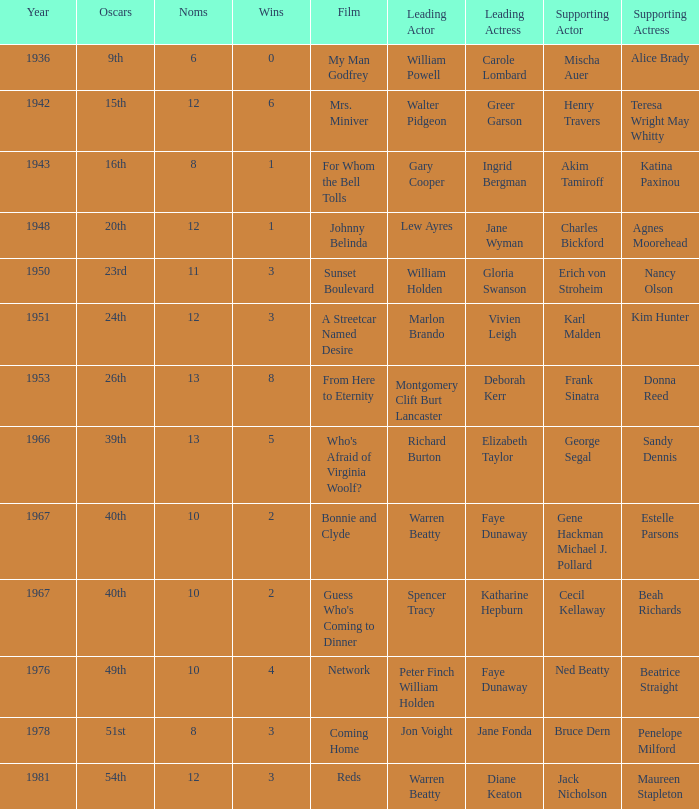Parse the full table. {'header': ['Year', 'Oscars', 'Noms', 'Wins', 'Film', 'Leading Actor', 'Leading Actress', 'Supporting Actor', 'Supporting Actress'], 'rows': [['1936', '9th', '6', '0', 'My Man Godfrey', 'William Powell', 'Carole Lombard', 'Mischa Auer', 'Alice Brady'], ['1942', '15th', '12', '6', 'Mrs. Miniver', 'Walter Pidgeon', 'Greer Garson', 'Henry Travers', 'Teresa Wright May Whitty'], ['1943', '16th', '8', '1', 'For Whom the Bell Tolls', 'Gary Cooper', 'Ingrid Bergman', 'Akim Tamiroff', 'Katina Paxinou'], ['1948', '20th', '12', '1', 'Johnny Belinda', 'Lew Ayres', 'Jane Wyman', 'Charles Bickford', 'Agnes Moorehead'], ['1950', '23rd', '11', '3', 'Sunset Boulevard', 'William Holden', 'Gloria Swanson', 'Erich von Stroheim', 'Nancy Olson'], ['1951', '24th', '12', '3', 'A Streetcar Named Desire', 'Marlon Brando', 'Vivien Leigh', 'Karl Malden', 'Kim Hunter'], ['1953', '26th', '13', '8', 'From Here to Eternity', 'Montgomery Clift Burt Lancaster', 'Deborah Kerr', 'Frank Sinatra', 'Donna Reed'], ['1966', '39th', '13', '5', "Who's Afraid of Virginia Woolf?", 'Richard Burton', 'Elizabeth Taylor', 'George Segal', 'Sandy Dennis'], ['1967', '40th', '10', '2', 'Bonnie and Clyde', 'Warren Beatty', 'Faye Dunaway', 'Gene Hackman Michael J. Pollard', 'Estelle Parsons'], ['1967', '40th', '10', '2', "Guess Who's Coming to Dinner", 'Spencer Tracy', 'Katharine Hepburn', 'Cecil Kellaway', 'Beah Richards'], ['1976', '49th', '10', '4', 'Network', 'Peter Finch William Holden', 'Faye Dunaway', 'Ned Beatty', 'Beatrice Straight'], ['1978', '51st', '8', '3', 'Coming Home', 'Jon Voight', 'Jane Fonda', 'Bruce Dern', 'Penelope Milford'], ['1981', '54th', '12', '3', 'Reds', 'Warren Beatty', 'Diane Keaton', 'Jack Nicholson', 'Maureen Stapleton']]} Which film had Charles Bickford as supporting actor? Johnny Belinda. 